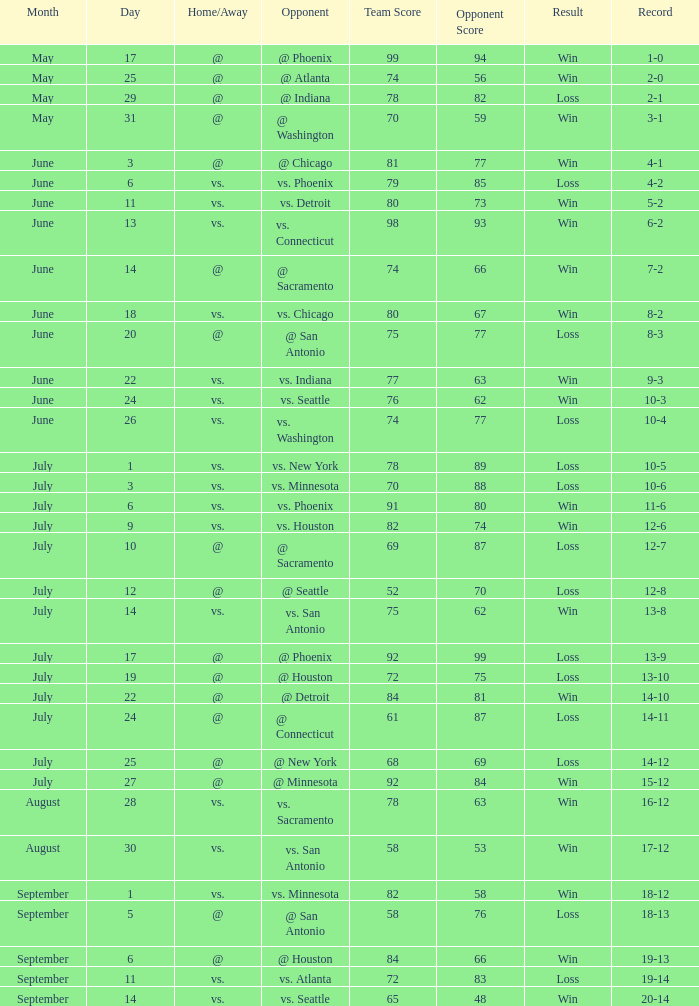What is the Record of the game with a Score of 65-48? 20-14. 